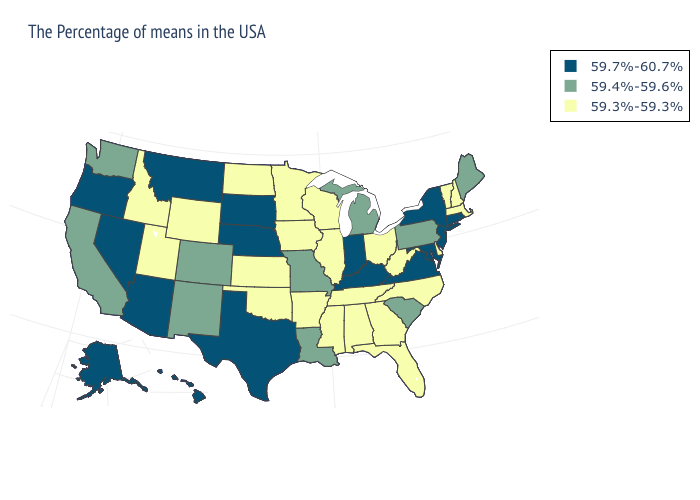What is the value of Wisconsin?
Short answer required. 59.3%-59.3%. What is the value of Wyoming?
Give a very brief answer. 59.3%-59.3%. What is the highest value in states that border New York?
Quick response, please. 59.7%-60.7%. What is the highest value in the MidWest ?
Be succinct. 59.7%-60.7%. Does Maryland have the highest value in the South?
Answer briefly. Yes. Does the map have missing data?
Concise answer only. No. What is the lowest value in states that border Massachusetts?
Give a very brief answer. 59.3%-59.3%. Does Missouri have the highest value in the USA?
Concise answer only. No. Among the states that border Ohio , does Indiana have the highest value?
Short answer required. Yes. Among the states that border New Jersey , which have the highest value?
Be succinct. New York. Does the map have missing data?
Keep it brief. No. What is the highest value in the Northeast ?
Short answer required. 59.7%-60.7%. What is the highest value in the USA?
Be succinct. 59.7%-60.7%. Among the states that border New Jersey , does New York have the highest value?
Concise answer only. Yes. Does Maryland have a lower value than Kentucky?
Be succinct. No. 